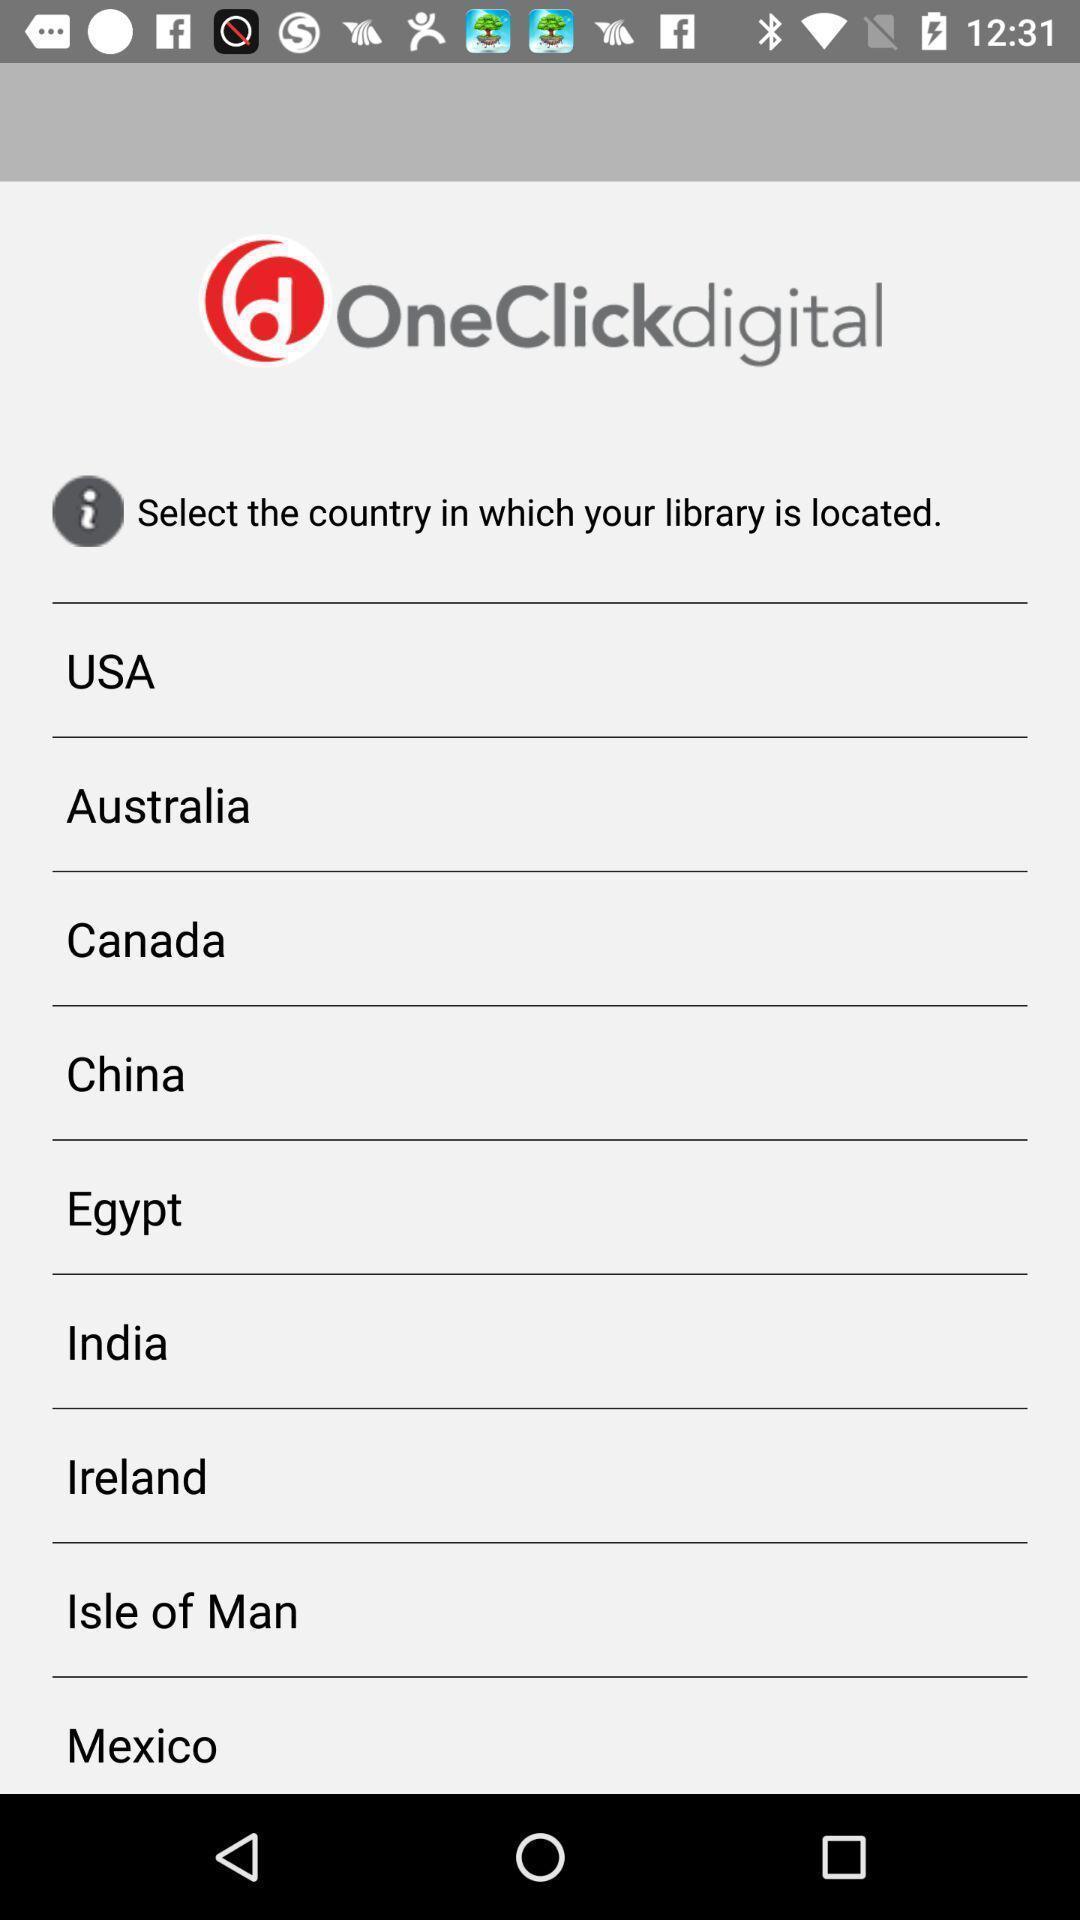Tell me about the visual elements in this screen capture. Screen displaying multiple country names in audio book application. 